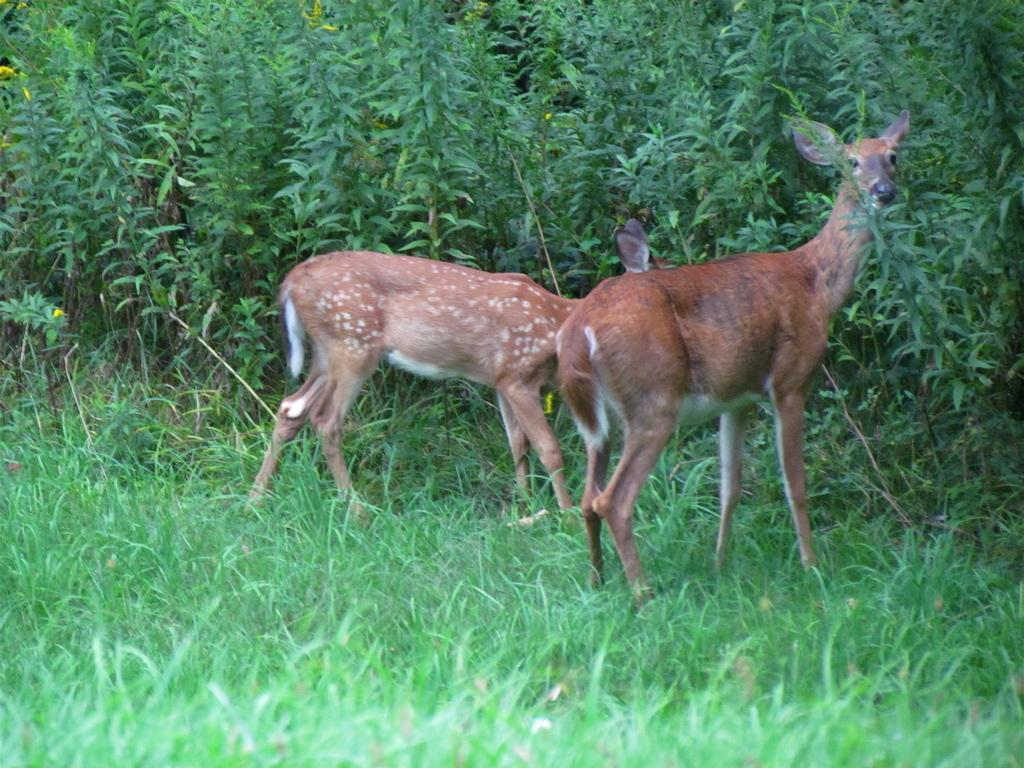What animals can be seen in the image? There are two deer in the image. Where are the deer located? The deer are standing on the grass. What can be seen in the background of the image? There are plants visible in the background of the image. What type of prose is the writer asking in the image? There is no writer or prose present in the image; it features two deer standing on the grass with plants in the background. 